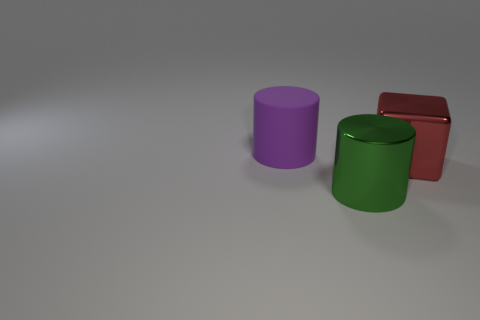Subtract all cylinders. How many objects are left? 1 Add 2 shiny cylinders. How many shiny cylinders are left? 3 Add 3 large red metallic blocks. How many large red metallic blocks exist? 4 Add 2 green cylinders. How many objects exist? 5 Subtract 0 blue cubes. How many objects are left? 3 Subtract all brown blocks. Subtract all brown balls. How many blocks are left? 1 Subtract all green spheres. How many purple cylinders are left? 1 Subtract all green metal cylinders. Subtract all red rubber spheres. How many objects are left? 2 